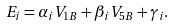Convert formula to latex. <formula><loc_0><loc_0><loc_500><loc_500>E _ { i } = \alpha _ { i } V _ { 1 B } + \beta _ { i } V _ { 5 B } + \gamma _ { i } .</formula> 